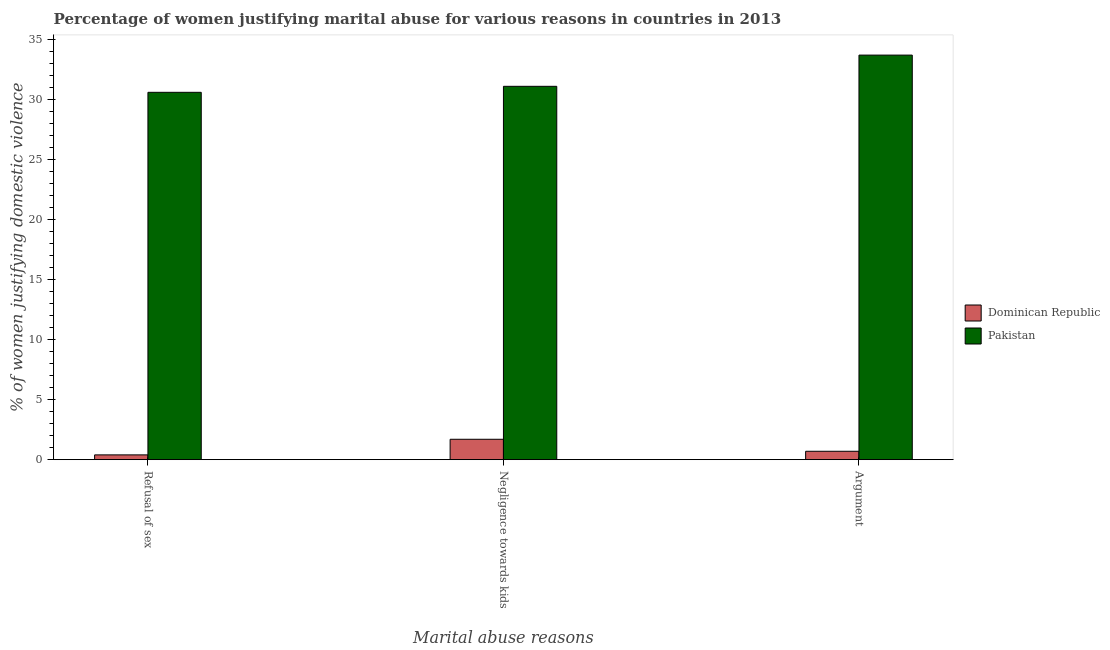How many different coloured bars are there?
Give a very brief answer. 2. How many bars are there on the 3rd tick from the left?
Provide a short and direct response. 2. What is the label of the 1st group of bars from the left?
Offer a very short reply. Refusal of sex. What is the percentage of women justifying domestic violence due to arguments in Pakistan?
Your answer should be very brief. 33.7. Across all countries, what is the maximum percentage of women justifying domestic violence due to negligence towards kids?
Your answer should be compact. 31.1. Across all countries, what is the minimum percentage of women justifying domestic violence due to negligence towards kids?
Your response must be concise. 1.7. In which country was the percentage of women justifying domestic violence due to refusal of sex minimum?
Offer a very short reply. Dominican Republic. What is the total percentage of women justifying domestic violence due to arguments in the graph?
Your answer should be compact. 34.4. What is the difference between the percentage of women justifying domestic violence due to arguments in Dominican Republic and that in Pakistan?
Make the answer very short. -33. What is the difference between the percentage of women justifying domestic violence due to refusal of sex in Pakistan and the percentage of women justifying domestic violence due to negligence towards kids in Dominican Republic?
Provide a short and direct response. 28.9. What is the difference between the percentage of women justifying domestic violence due to negligence towards kids and percentage of women justifying domestic violence due to refusal of sex in Dominican Republic?
Your response must be concise. 1.3. What is the ratio of the percentage of women justifying domestic violence due to negligence towards kids in Dominican Republic to that in Pakistan?
Ensure brevity in your answer.  0.05. Is the percentage of women justifying domestic violence due to refusal of sex in Pakistan less than that in Dominican Republic?
Keep it short and to the point. No. Is the difference between the percentage of women justifying domestic violence due to negligence towards kids in Pakistan and Dominican Republic greater than the difference between the percentage of women justifying domestic violence due to refusal of sex in Pakistan and Dominican Republic?
Keep it short and to the point. No. What is the difference between the highest and the second highest percentage of women justifying domestic violence due to arguments?
Provide a succinct answer. 33. What is the difference between the highest and the lowest percentage of women justifying domestic violence due to refusal of sex?
Provide a short and direct response. 30.2. In how many countries, is the percentage of women justifying domestic violence due to arguments greater than the average percentage of women justifying domestic violence due to arguments taken over all countries?
Offer a terse response. 1. Is the sum of the percentage of women justifying domestic violence due to refusal of sex in Pakistan and Dominican Republic greater than the maximum percentage of women justifying domestic violence due to arguments across all countries?
Offer a very short reply. No. What does the 2nd bar from the left in Refusal of sex represents?
Offer a very short reply. Pakistan. What does the 2nd bar from the right in Negligence towards kids represents?
Your answer should be very brief. Dominican Republic. Is it the case that in every country, the sum of the percentage of women justifying domestic violence due to refusal of sex and percentage of women justifying domestic violence due to negligence towards kids is greater than the percentage of women justifying domestic violence due to arguments?
Your answer should be compact. Yes. How many countries are there in the graph?
Your answer should be very brief. 2. What is the difference between two consecutive major ticks on the Y-axis?
Keep it short and to the point. 5. Does the graph contain any zero values?
Make the answer very short. No. Where does the legend appear in the graph?
Provide a short and direct response. Center right. How many legend labels are there?
Offer a very short reply. 2. How are the legend labels stacked?
Give a very brief answer. Vertical. What is the title of the graph?
Give a very brief answer. Percentage of women justifying marital abuse for various reasons in countries in 2013. Does "Slovak Republic" appear as one of the legend labels in the graph?
Your response must be concise. No. What is the label or title of the X-axis?
Your answer should be very brief. Marital abuse reasons. What is the label or title of the Y-axis?
Provide a short and direct response. % of women justifying domestic violence. What is the % of women justifying domestic violence of Dominican Republic in Refusal of sex?
Your answer should be compact. 0.4. What is the % of women justifying domestic violence in Pakistan in Refusal of sex?
Your answer should be very brief. 30.6. What is the % of women justifying domestic violence in Pakistan in Negligence towards kids?
Give a very brief answer. 31.1. What is the % of women justifying domestic violence of Dominican Republic in Argument?
Keep it short and to the point. 0.7. What is the % of women justifying domestic violence in Pakistan in Argument?
Offer a very short reply. 33.7. Across all Marital abuse reasons, what is the maximum % of women justifying domestic violence of Dominican Republic?
Make the answer very short. 1.7. Across all Marital abuse reasons, what is the maximum % of women justifying domestic violence in Pakistan?
Provide a succinct answer. 33.7. Across all Marital abuse reasons, what is the minimum % of women justifying domestic violence in Dominican Republic?
Give a very brief answer. 0.4. Across all Marital abuse reasons, what is the minimum % of women justifying domestic violence of Pakistan?
Provide a short and direct response. 30.6. What is the total % of women justifying domestic violence of Pakistan in the graph?
Give a very brief answer. 95.4. What is the difference between the % of women justifying domestic violence of Dominican Republic in Refusal of sex and that in Negligence towards kids?
Provide a short and direct response. -1.3. What is the difference between the % of women justifying domestic violence in Pakistan in Refusal of sex and that in Negligence towards kids?
Ensure brevity in your answer.  -0.5. What is the difference between the % of women justifying domestic violence of Pakistan in Refusal of sex and that in Argument?
Give a very brief answer. -3.1. What is the difference between the % of women justifying domestic violence of Dominican Republic in Negligence towards kids and that in Argument?
Make the answer very short. 1. What is the difference between the % of women justifying domestic violence of Pakistan in Negligence towards kids and that in Argument?
Make the answer very short. -2.6. What is the difference between the % of women justifying domestic violence in Dominican Republic in Refusal of sex and the % of women justifying domestic violence in Pakistan in Negligence towards kids?
Your response must be concise. -30.7. What is the difference between the % of women justifying domestic violence in Dominican Republic in Refusal of sex and the % of women justifying domestic violence in Pakistan in Argument?
Make the answer very short. -33.3. What is the difference between the % of women justifying domestic violence in Dominican Republic in Negligence towards kids and the % of women justifying domestic violence in Pakistan in Argument?
Ensure brevity in your answer.  -32. What is the average % of women justifying domestic violence in Dominican Republic per Marital abuse reasons?
Keep it short and to the point. 0.93. What is the average % of women justifying domestic violence in Pakistan per Marital abuse reasons?
Offer a very short reply. 31.8. What is the difference between the % of women justifying domestic violence in Dominican Republic and % of women justifying domestic violence in Pakistan in Refusal of sex?
Your answer should be very brief. -30.2. What is the difference between the % of women justifying domestic violence of Dominican Republic and % of women justifying domestic violence of Pakistan in Negligence towards kids?
Make the answer very short. -29.4. What is the difference between the % of women justifying domestic violence in Dominican Republic and % of women justifying domestic violence in Pakistan in Argument?
Your answer should be compact. -33. What is the ratio of the % of women justifying domestic violence of Dominican Republic in Refusal of sex to that in Negligence towards kids?
Provide a short and direct response. 0.24. What is the ratio of the % of women justifying domestic violence of Pakistan in Refusal of sex to that in Negligence towards kids?
Provide a short and direct response. 0.98. What is the ratio of the % of women justifying domestic violence in Pakistan in Refusal of sex to that in Argument?
Make the answer very short. 0.91. What is the ratio of the % of women justifying domestic violence in Dominican Republic in Negligence towards kids to that in Argument?
Your answer should be compact. 2.43. What is the ratio of the % of women justifying domestic violence in Pakistan in Negligence towards kids to that in Argument?
Your response must be concise. 0.92. What is the difference between the highest and the second highest % of women justifying domestic violence of Dominican Republic?
Your answer should be very brief. 1. What is the difference between the highest and the second highest % of women justifying domestic violence in Pakistan?
Give a very brief answer. 2.6. What is the difference between the highest and the lowest % of women justifying domestic violence in Pakistan?
Offer a terse response. 3.1. 